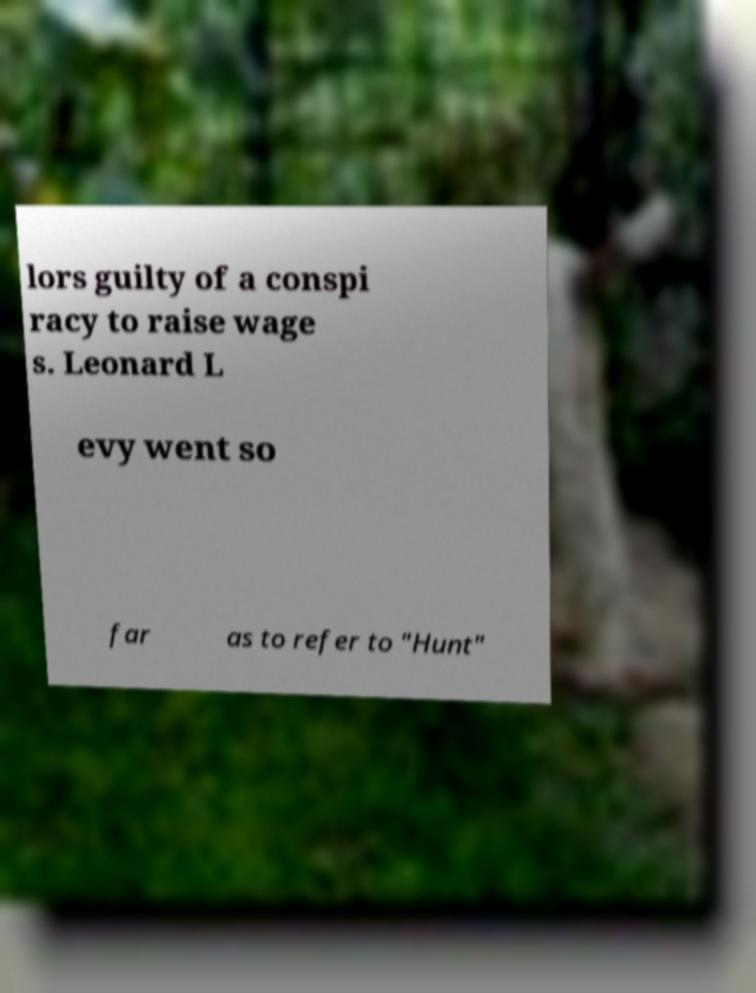There's text embedded in this image that I need extracted. Can you transcribe it verbatim? lors guilty of a conspi racy to raise wage s. Leonard L evy went so far as to refer to "Hunt" 